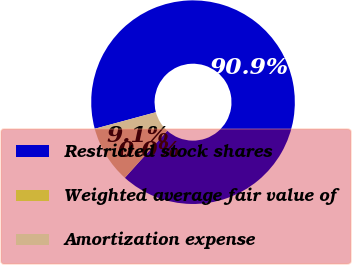Convert chart to OTSL. <chart><loc_0><loc_0><loc_500><loc_500><pie_chart><fcel>Restricted stock shares<fcel>Weighted average fair value of<fcel>Amortization expense<nl><fcel>90.88%<fcel>0.02%<fcel>9.1%<nl></chart> 